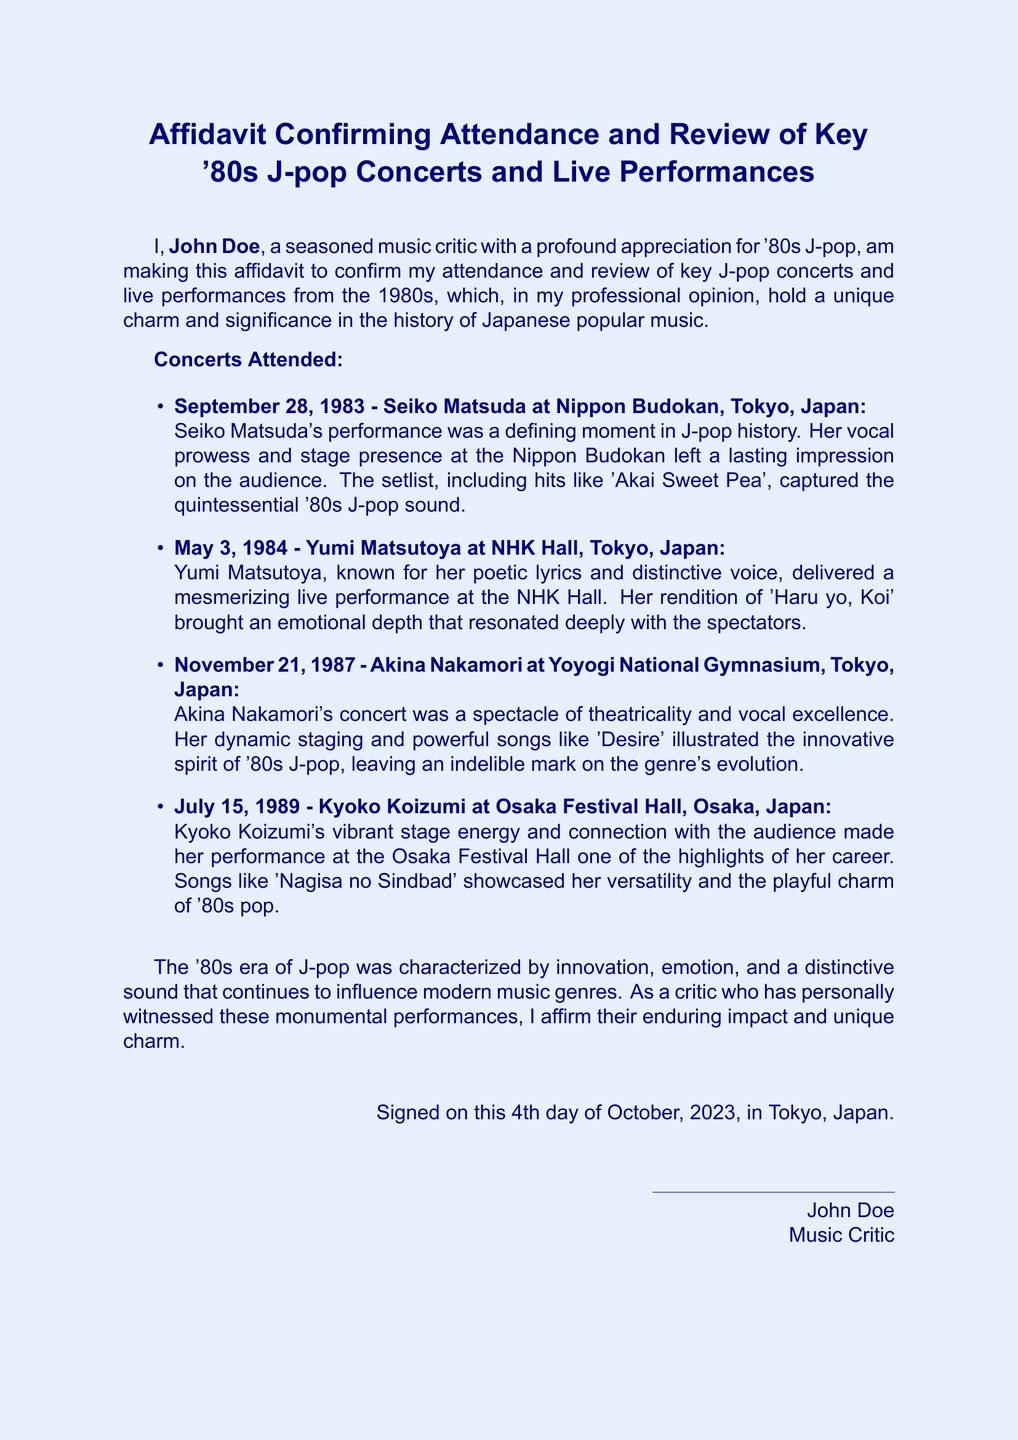What is the name of the music critic? The name of the music critic is stated at the beginning of the affidavit as John Doe.
Answer: John Doe What is the date of Seiko Matsuda's concert? The date of Seiko Matsuda's concert is mentioned specifically in the document as September 28, 1983.
Answer: September 28, 1983 Which venue hosted Yumi Matsutoya's concert? The venue for Yumi Matsutoya's concert is indicated as NHK Hall, Tokyo, Japan.
Answer: NHK Hall, Tokyo, Japan How many concerts are listed in the affidavit? The document outlines a total of four concerts attended and reviewed by the critic.
Answer: Four What song did Akina Nakamori perform at her concert? The affidavit mentions that Akina Nakamori performed the song 'Desire' during her concert.
Answer: 'Desire' What aspect of '80s J-pop does the critic emphasize? The critic emphasizes innovation, emotion, and a distinctive sound in '80s J-pop.
Answer: Innovation, emotion, and a distinctive sound When was the affidavit signed? The affidavit was signed on the 4th day of October, 2023.
Answer: October 4, 2023 Where did Kyoko Koizumi perform? The affidavit specifies that Kyoko Koizumi performed at Osaka Festival Hall, Osaka, Japan.
Answer: Osaka Festival Hall, Osaka, Japan 